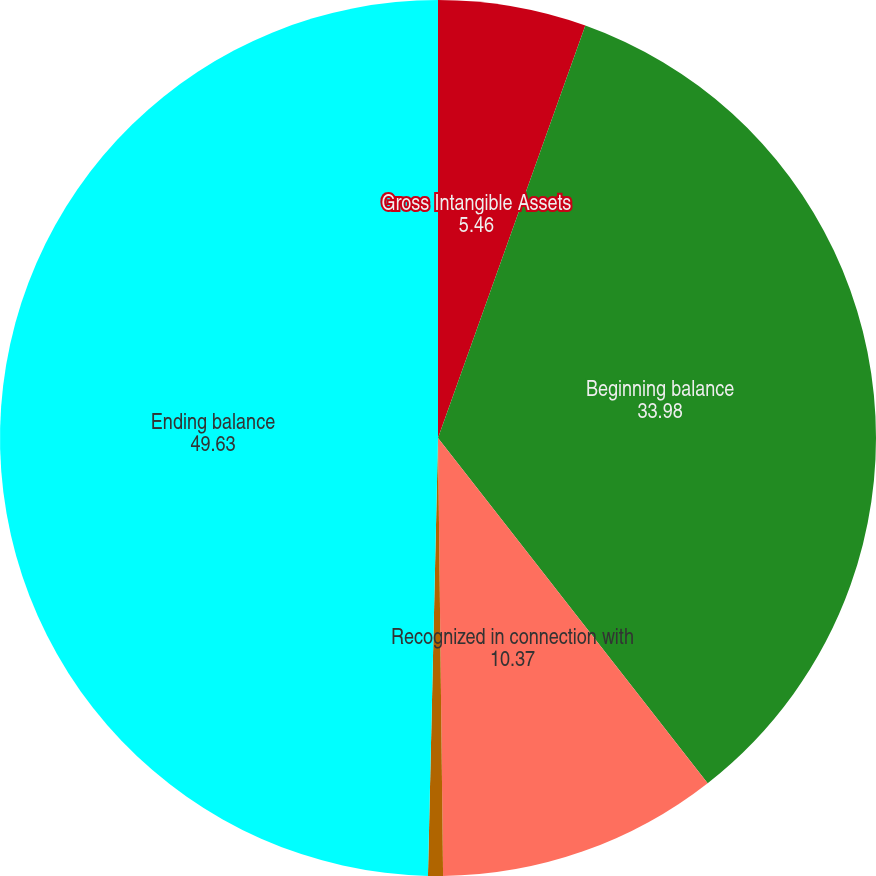<chart> <loc_0><loc_0><loc_500><loc_500><pie_chart><fcel>Gross Intangible Assets<fcel>Beginning balance<fcel>Recognized in connection with<fcel>Impairment charges and other<fcel>Ending balance<nl><fcel>5.46%<fcel>33.98%<fcel>10.37%<fcel>0.55%<fcel>49.63%<nl></chart> 